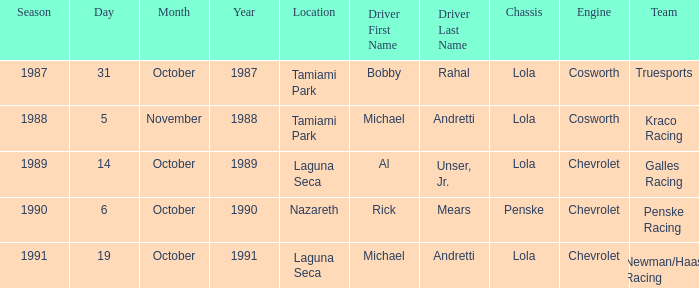What was the date of the race in nazareth? October 6. 